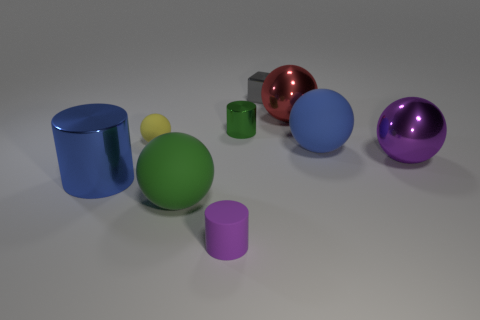Are the large blue sphere and the red thing made of the same material?
Provide a short and direct response. No. There is a green thing in front of the yellow sphere on the right side of the blue metal thing; what is its material?
Ensure brevity in your answer.  Rubber. What number of tiny things are blue balls or gray shiny cubes?
Offer a very short reply. 1. How big is the gray shiny object?
Make the answer very short. Small. Is the number of gray metallic objects that are in front of the small purple cylinder greater than the number of large red objects?
Provide a short and direct response. No. Are there the same number of shiny cubes that are to the left of the large green thing and purple metal things left of the tiny yellow sphere?
Give a very brief answer. Yes. What color is the matte object that is on the right side of the green sphere and behind the tiny purple rubber cylinder?
Offer a terse response. Blue. Is there anything else that has the same size as the gray shiny cube?
Offer a very short reply. Yes. Is the number of small green things that are on the right side of the red metallic object greater than the number of spheres in front of the blue metal cylinder?
Provide a succinct answer. No. Is the size of the green object left of the green metallic object the same as the purple ball?
Your answer should be compact. Yes. 